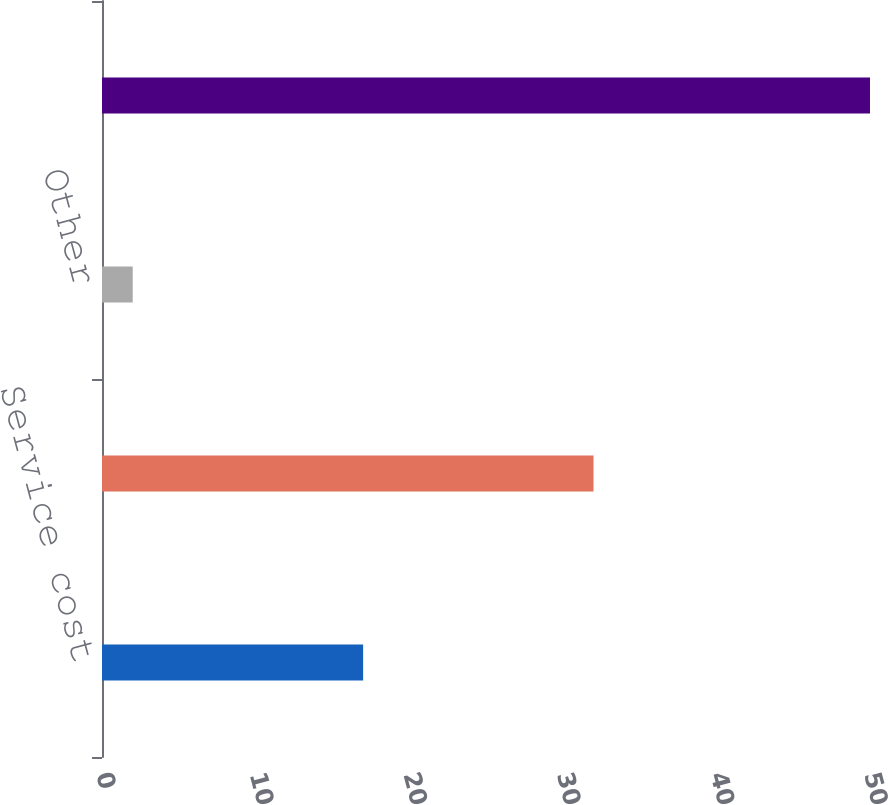Convert chart to OTSL. <chart><loc_0><loc_0><loc_500><loc_500><bar_chart><fcel>Service cost<fcel>Interest cost<fcel>Other<fcel>Net periodic benefit cost<nl><fcel>17<fcel>32<fcel>2<fcel>50<nl></chart> 